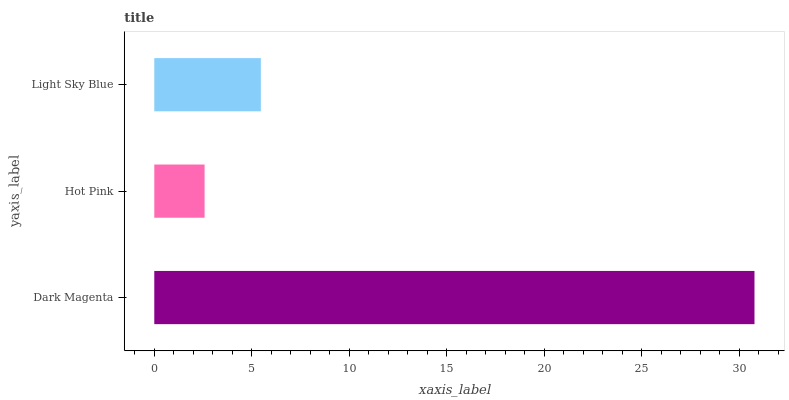Is Hot Pink the minimum?
Answer yes or no. Yes. Is Dark Magenta the maximum?
Answer yes or no. Yes. Is Light Sky Blue the minimum?
Answer yes or no. No. Is Light Sky Blue the maximum?
Answer yes or no. No. Is Light Sky Blue greater than Hot Pink?
Answer yes or no. Yes. Is Hot Pink less than Light Sky Blue?
Answer yes or no. Yes. Is Hot Pink greater than Light Sky Blue?
Answer yes or no. No. Is Light Sky Blue less than Hot Pink?
Answer yes or no. No. Is Light Sky Blue the high median?
Answer yes or no. Yes. Is Light Sky Blue the low median?
Answer yes or no. Yes. Is Dark Magenta the high median?
Answer yes or no. No. Is Dark Magenta the low median?
Answer yes or no. No. 